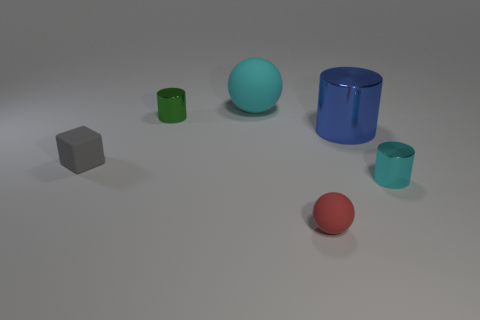Subtract all balls. How many objects are left? 4 Subtract 1 balls. How many balls are left? 1 Subtract all cyan cylinders. Subtract all yellow blocks. How many cylinders are left? 2 Subtract all blue spheres. How many cyan cylinders are left? 1 Subtract all big brown metal balls. Subtract all metal things. How many objects are left? 3 Add 3 cyan metallic cylinders. How many cyan metallic cylinders are left? 4 Add 2 large cylinders. How many large cylinders exist? 3 Add 2 green shiny spheres. How many objects exist? 8 Subtract all red spheres. How many spheres are left? 1 Subtract all big blue cylinders. How many cylinders are left? 2 